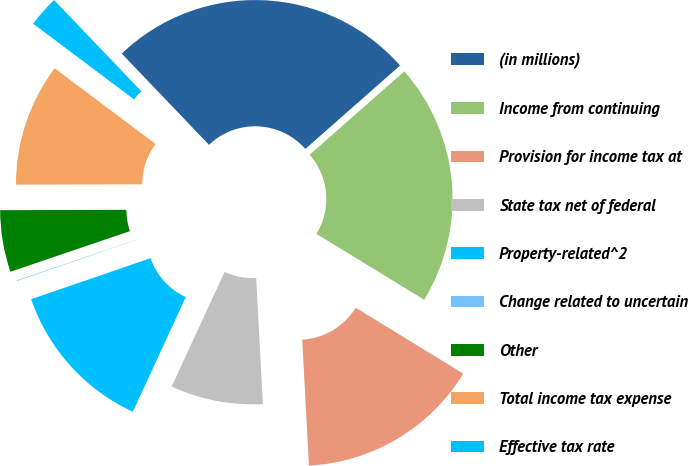Convert chart. <chart><loc_0><loc_0><loc_500><loc_500><pie_chart><fcel>(in millions)<fcel>Income from continuing<fcel>Provision for income tax at<fcel>State tax net of federal<fcel>Property-related^2<fcel>Change related to uncertain<fcel>Other<fcel>Total income tax expense<fcel>Effective tax rate<nl><fcel>25.65%<fcel>20.23%<fcel>15.41%<fcel>7.73%<fcel>12.85%<fcel>0.05%<fcel>5.17%<fcel>10.29%<fcel>2.61%<nl></chart> 